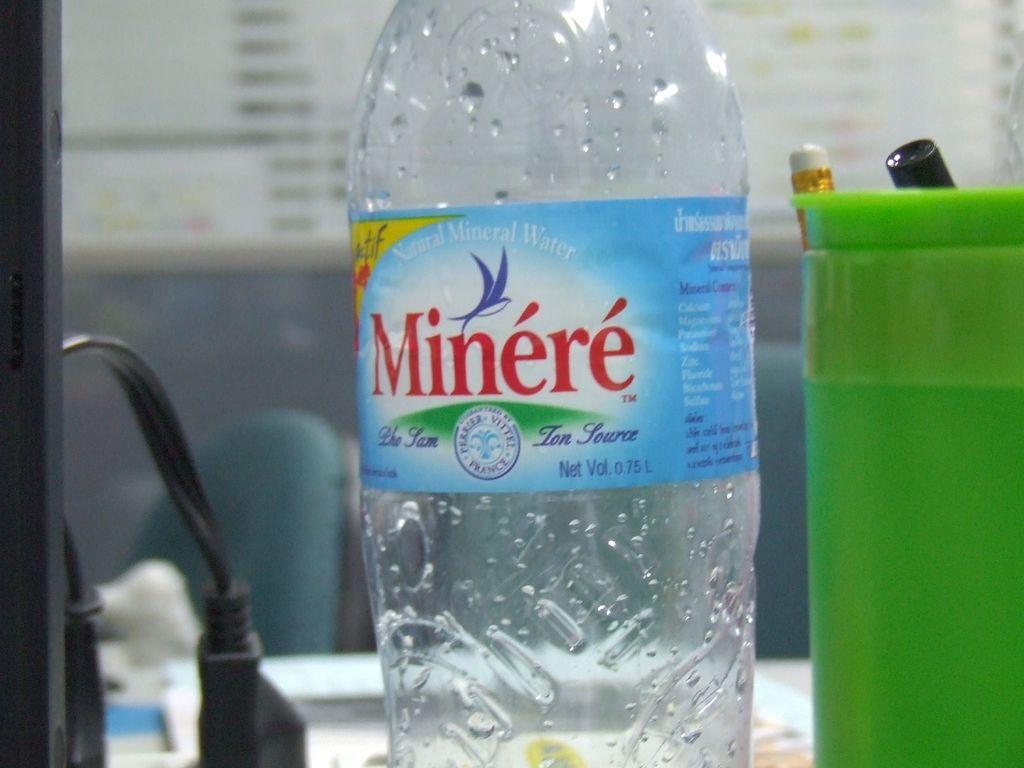Please provide a concise description of this image. In this picture there is a empty bottle, the bottle is neatly labelled and some text printed on the table. Towards the right there is a jar, one pencil and a marker. In the left there is a wire. 